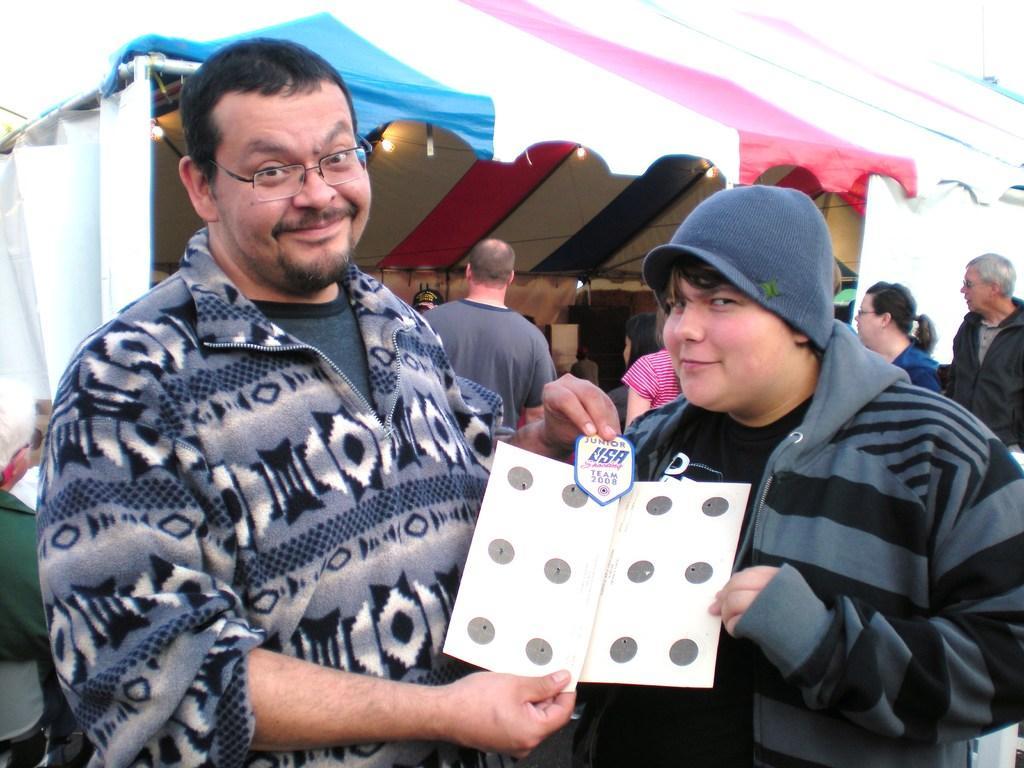How would you summarize this image in a sentence or two? There are people in the center of the image holding a paper in their hands. There are other people, a stall and lamps in the background. 